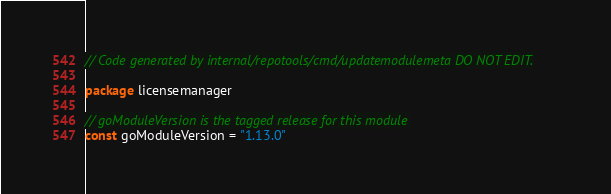<code> <loc_0><loc_0><loc_500><loc_500><_Go_>// Code generated by internal/repotools/cmd/updatemodulemeta DO NOT EDIT.

package licensemanager

// goModuleVersion is the tagged release for this module
const goModuleVersion = "1.13.0"
</code> 